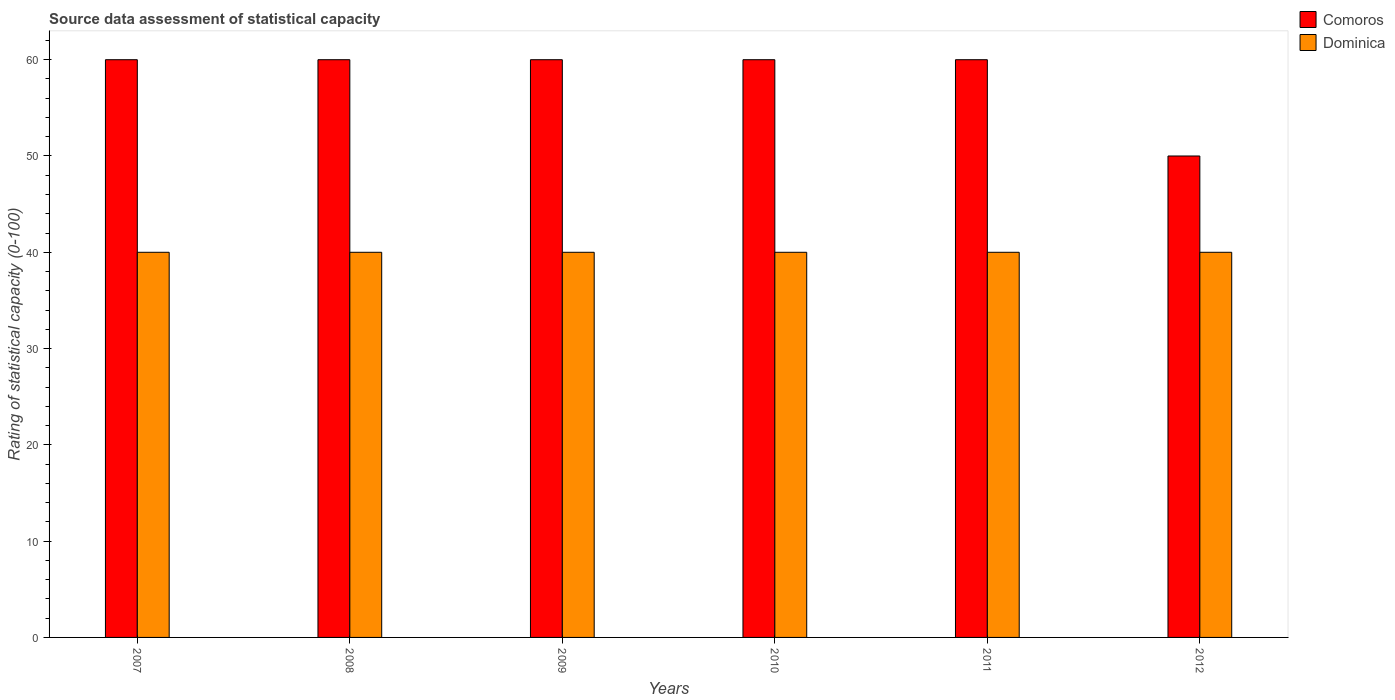How many different coloured bars are there?
Provide a short and direct response. 2. Are the number of bars per tick equal to the number of legend labels?
Your answer should be very brief. Yes. Are the number of bars on each tick of the X-axis equal?
Your answer should be very brief. Yes. How many bars are there on the 2nd tick from the left?
Provide a short and direct response. 2. How many bars are there on the 5th tick from the right?
Your answer should be very brief. 2. What is the label of the 6th group of bars from the left?
Provide a succinct answer. 2012. In how many cases, is the number of bars for a given year not equal to the number of legend labels?
Ensure brevity in your answer.  0. What is the rating of statistical capacity in Dominica in 2008?
Ensure brevity in your answer.  40. Across all years, what is the maximum rating of statistical capacity in Dominica?
Your response must be concise. 40. Across all years, what is the minimum rating of statistical capacity in Comoros?
Your response must be concise. 50. What is the total rating of statistical capacity in Comoros in the graph?
Your answer should be very brief. 350. What is the difference between the rating of statistical capacity in Comoros in 2008 and that in 2009?
Provide a succinct answer. 0. What is the difference between the rating of statistical capacity in Comoros in 2008 and the rating of statistical capacity in Dominica in 2011?
Provide a short and direct response. 20. What is the average rating of statistical capacity in Comoros per year?
Your answer should be compact. 58.33. In the year 2012, what is the difference between the rating of statistical capacity in Comoros and rating of statistical capacity in Dominica?
Give a very brief answer. 10. Is the rating of statistical capacity in Comoros in 2007 less than that in 2008?
Offer a terse response. No. Is the difference between the rating of statistical capacity in Comoros in 2010 and 2012 greater than the difference between the rating of statistical capacity in Dominica in 2010 and 2012?
Ensure brevity in your answer.  Yes. In how many years, is the rating of statistical capacity in Dominica greater than the average rating of statistical capacity in Dominica taken over all years?
Your response must be concise. 0. What does the 1st bar from the left in 2009 represents?
Make the answer very short. Comoros. What does the 1st bar from the right in 2012 represents?
Your response must be concise. Dominica. How many bars are there?
Provide a succinct answer. 12. Are the values on the major ticks of Y-axis written in scientific E-notation?
Offer a very short reply. No. Does the graph contain grids?
Offer a terse response. No. Where does the legend appear in the graph?
Offer a very short reply. Top right. How are the legend labels stacked?
Offer a very short reply. Vertical. What is the title of the graph?
Make the answer very short. Source data assessment of statistical capacity. Does "Isle of Man" appear as one of the legend labels in the graph?
Provide a short and direct response. No. What is the label or title of the Y-axis?
Keep it short and to the point. Rating of statistical capacity (0-100). What is the Rating of statistical capacity (0-100) of Comoros in 2007?
Ensure brevity in your answer.  60. What is the Rating of statistical capacity (0-100) of Comoros in 2008?
Offer a very short reply. 60. What is the Rating of statistical capacity (0-100) of Comoros in 2009?
Your answer should be very brief. 60. What is the Rating of statistical capacity (0-100) in Dominica in 2009?
Ensure brevity in your answer.  40. What is the Rating of statistical capacity (0-100) of Dominica in 2010?
Your answer should be compact. 40. What is the Rating of statistical capacity (0-100) in Comoros in 2011?
Keep it short and to the point. 60. What is the Rating of statistical capacity (0-100) in Dominica in 2011?
Make the answer very short. 40. Across all years, what is the maximum Rating of statistical capacity (0-100) in Dominica?
Provide a short and direct response. 40. Across all years, what is the minimum Rating of statistical capacity (0-100) of Comoros?
Make the answer very short. 50. Across all years, what is the minimum Rating of statistical capacity (0-100) in Dominica?
Give a very brief answer. 40. What is the total Rating of statistical capacity (0-100) of Comoros in the graph?
Give a very brief answer. 350. What is the total Rating of statistical capacity (0-100) in Dominica in the graph?
Offer a terse response. 240. What is the difference between the Rating of statistical capacity (0-100) of Comoros in 2007 and that in 2008?
Offer a very short reply. 0. What is the difference between the Rating of statistical capacity (0-100) in Dominica in 2007 and that in 2010?
Ensure brevity in your answer.  0. What is the difference between the Rating of statistical capacity (0-100) in Comoros in 2007 and that in 2011?
Keep it short and to the point. 0. What is the difference between the Rating of statistical capacity (0-100) in Dominica in 2007 and that in 2011?
Ensure brevity in your answer.  0. What is the difference between the Rating of statistical capacity (0-100) of Comoros in 2007 and that in 2012?
Offer a very short reply. 10. What is the difference between the Rating of statistical capacity (0-100) in Dominica in 2007 and that in 2012?
Your answer should be very brief. 0. What is the difference between the Rating of statistical capacity (0-100) of Comoros in 2008 and that in 2009?
Your answer should be compact. 0. What is the difference between the Rating of statistical capacity (0-100) in Comoros in 2008 and that in 2010?
Your answer should be very brief. 0. What is the difference between the Rating of statistical capacity (0-100) in Comoros in 2008 and that in 2011?
Your answer should be compact. 0. What is the difference between the Rating of statistical capacity (0-100) of Dominica in 2008 and that in 2011?
Provide a succinct answer. 0. What is the difference between the Rating of statistical capacity (0-100) in Dominica in 2008 and that in 2012?
Offer a terse response. 0. What is the difference between the Rating of statistical capacity (0-100) in Comoros in 2009 and that in 2011?
Provide a short and direct response. 0. What is the difference between the Rating of statistical capacity (0-100) of Comoros in 2009 and that in 2012?
Offer a very short reply. 10. What is the difference between the Rating of statistical capacity (0-100) of Comoros in 2010 and that in 2012?
Your answer should be compact. 10. What is the difference between the Rating of statistical capacity (0-100) of Dominica in 2010 and that in 2012?
Your answer should be compact. 0. What is the difference between the Rating of statistical capacity (0-100) in Comoros in 2011 and that in 2012?
Provide a succinct answer. 10. What is the difference between the Rating of statistical capacity (0-100) of Comoros in 2007 and the Rating of statistical capacity (0-100) of Dominica in 2008?
Your response must be concise. 20. What is the difference between the Rating of statistical capacity (0-100) in Comoros in 2007 and the Rating of statistical capacity (0-100) in Dominica in 2009?
Make the answer very short. 20. What is the difference between the Rating of statistical capacity (0-100) in Comoros in 2007 and the Rating of statistical capacity (0-100) in Dominica in 2011?
Your response must be concise. 20. What is the difference between the Rating of statistical capacity (0-100) in Comoros in 2007 and the Rating of statistical capacity (0-100) in Dominica in 2012?
Provide a succinct answer. 20. What is the difference between the Rating of statistical capacity (0-100) in Comoros in 2010 and the Rating of statistical capacity (0-100) in Dominica in 2012?
Give a very brief answer. 20. What is the average Rating of statistical capacity (0-100) of Comoros per year?
Your response must be concise. 58.33. What is the ratio of the Rating of statistical capacity (0-100) in Comoros in 2007 to that in 2010?
Your answer should be very brief. 1. What is the ratio of the Rating of statistical capacity (0-100) in Dominica in 2007 to that in 2010?
Your answer should be compact. 1. What is the ratio of the Rating of statistical capacity (0-100) in Comoros in 2007 to that in 2012?
Your response must be concise. 1.2. What is the ratio of the Rating of statistical capacity (0-100) of Comoros in 2008 to that in 2009?
Offer a very short reply. 1. What is the ratio of the Rating of statistical capacity (0-100) of Comoros in 2008 to that in 2010?
Your answer should be compact. 1. What is the ratio of the Rating of statistical capacity (0-100) in Dominica in 2008 to that in 2010?
Your answer should be very brief. 1. What is the ratio of the Rating of statistical capacity (0-100) in Dominica in 2008 to that in 2011?
Your answer should be very brief. 1. What is the ratio of the Rating of statistical capacity (0-100) of Comoros in 2009 to that in 2010?
Ensure brevity in your answer.  1. What is the ratio of the Rating of statistical capacity (0-100) of Dominica in 2009 to that in 2010?
Make the answer very short. 1. What is the ratio of the Rating of statistical capacity (0-100) in Dominica in 2009 to that in 2011?
Your answer should be compact. 1. What is the ratio of the Rating of statistical capacity (0-100) of Comoros in 2010 to that in 2011?
Ensure brevity in your answer.  1. What is the ratio of the Rating of statistical capacity (0-100) of Dominica in 2010 to that in 2011?
Your answer should be very brief. 1. What is the ratio of the Rating of statistical capacity (0-100) of Comoros in 2011 to that in 2012?
Make the answer very short. 1.2. What is the ratio of the Rating of statistical capacity (0-100) of Dominica in 2011 to that in 2012?
Offer a very short reply. 1. What is the difference between the highest and the second highest Rating of statistical capacity (0-100) of Dominica?
Make the answer very short. 0. What is the difference between the highest and the lowest Rating of statistical capacity (0-100) of Comoros?
Make the answer very short. 10. What is the difference between the highest and the lowest Rating of statistical capacity (0-100) of Dominica?
Provide a succinct answer. 0. 